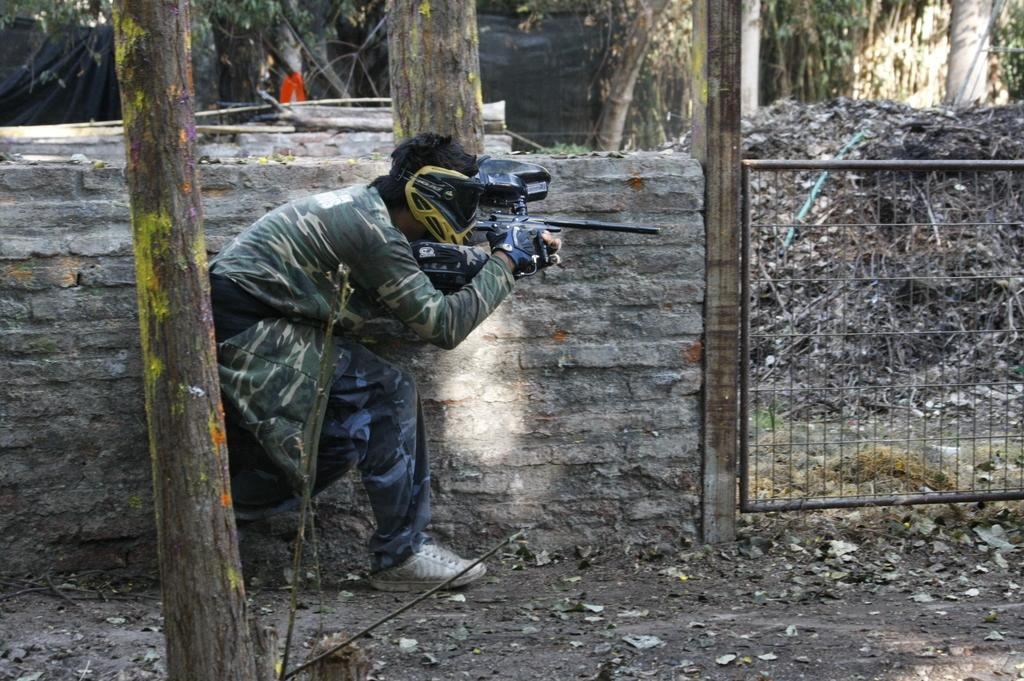What is the person in the image holding? The person is holding a gun in the image. What can be seen in the background of the image? There is a fence and trees in the image. What type of objects are made of wood in the image? There are wooden trunks in the image. What sense is being used by the person in the image? The provided facts do not mention any specific sense being used by the person in the image. --- Facts: 1. There is a person sitting on a chair in the image. 2. The person is holding a book. 3. There is a table next to the chair. 4. There is a lamp on the table. 5. The background of the image is a room. Absurd Topics: ocean, dance, elephant Conversation: What is the person in the image doing? The person is sitting on a chair in the image. What object is the person holding? The person is holding a book. What is located next to the chair? There is a table next to the chair. What is on the table? There is a lamp on the table. Reasoning: Let's think step by step in order to produce the conversation. We start by identifying the main subject in the image, which is the person sitting on a chair. Then, we expand the conversation to include other elements in the image, such as the book, table, and lamp. Each question is designed to elicit a specific detail about the image that is known from the provided facts. Absurd Question/Answer: Can you see any elephants in the image? No, there are no elephants present in the image. 